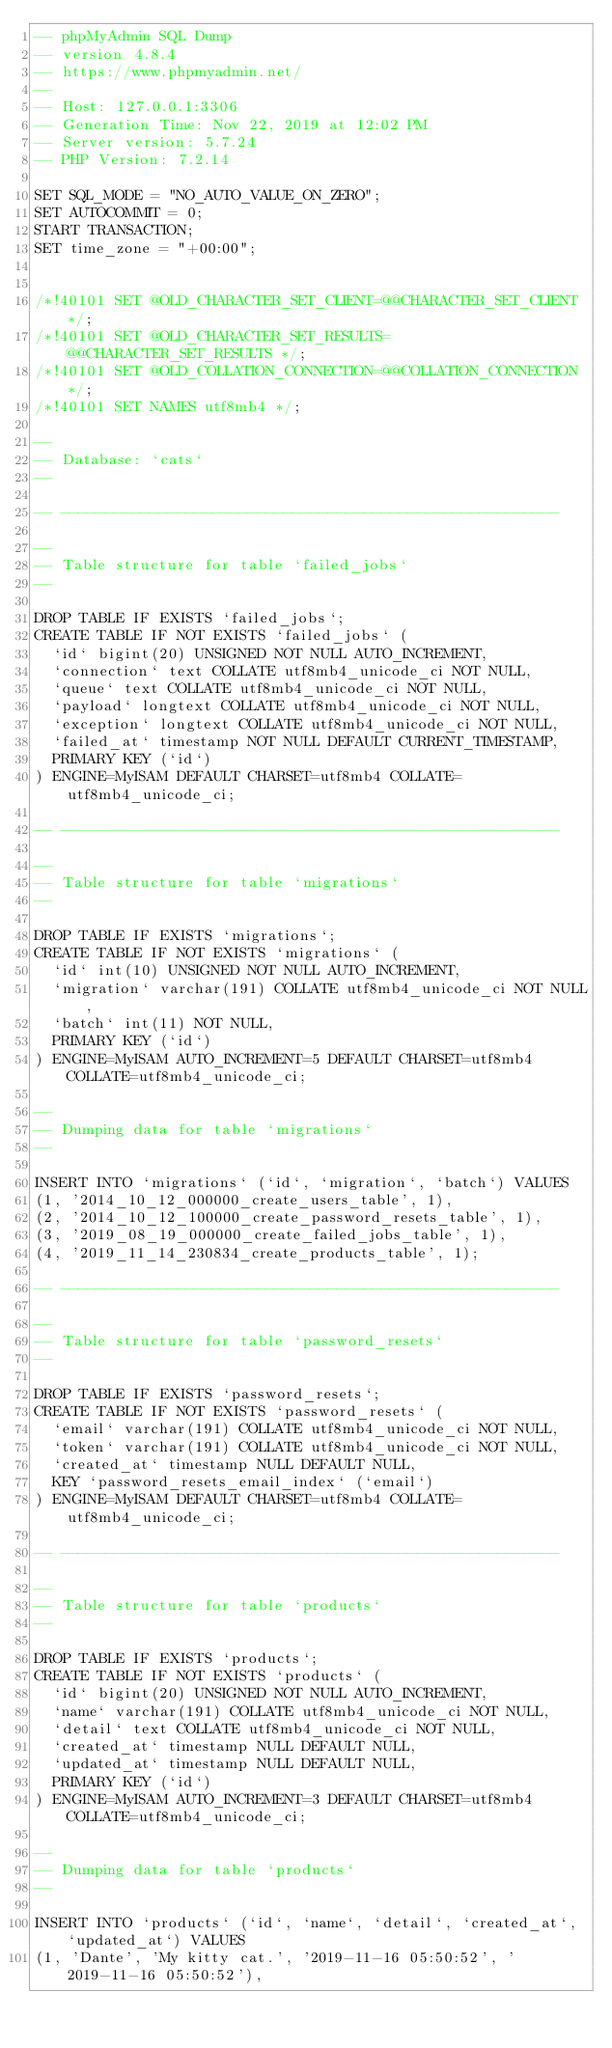<code> <loc_0><loc_0><loc_500><loc_500><_SQL_>-- phpMyAdmin SQL Dump
-- version 4.8.4
-- https://www.phpmyadmin.net/
--
-- Host: 127.0.0.1:3306
-- Generation Time: Nov 22, 2019 at 12:02 PM
-- Server version: 5.7.24
-- PHP Version: 7.2.14

SET SQL_MODE = "NO_AUTO_VALUE_ON_ZERO";
SET AUTOCOMMIT = 0;
START TRANSACTION;
SET time_zone = "+00:00";


/*!40101 SET @OLD_CHARACTER_SET_CLIENT=@@CHARACTER_SET_CLIENT */;
/*!40101 SET @OLD_CHARACTER_SET_RESULTS=@@CHARACTER_SET_RESULTS */;
/*!40101 SET @OLD_COLLATION_CONNECTION=@@COLLATION_CONNECTION */;
/*!40101 SET NAMES utf8mb4 */;

--
-- Database: `cats`
--

-- --------------------------------------------------------

--
-- Table structure for table `failed_jobs`
--

DROP TABLE IF EXISTS `failed_jobs`;
CREATE TABLE IF NOT EXISTS `failed_jobs` (
  `id` bigint(20) UNSIGNED NOT NULL AUTO_INCREMENT,
  `connection` text COLLATE utf8mb4_unicode_ci NOT NULL,
  `queue` text COLLATE utf8mb4_unicode_ci NOT NULL,
  `payload` longtext COLLATE utf8mb4_unicode_ci NOT NULL,
  `exception` longtext COLLATE utf8mb4_unicode_ci NOT NULL,
  `failed_at` timestamp NOT NULL DEFAULT CURRENT_TIMESTAMP,
  PRIMARY KEY (`id`)
) ENGINE=MyISAM DEFAULT CHARSET=utf8mb4 COLLATE=utf8mb4_unicode_ci;

-- --------------------------------------------------------

--
-- Table structure for table `migrations`
--

DROP TABLE IF EXISTS `migrations`;
CREATE TABLE IF NOT EXISTS `migrations` (
  `id` int(10) UNSIGNED NOT NULL AUTO_INCREMENT,
  `migration` varchar(191) COLLATE utf8mb4_unicode_ci NOT NULL,
  `batch` int(11) NOT NULL,
  PRIMARY KEY (`id`)
) ENGINE=MyISAM AUTO_INCREMENT=5 DEFAULT CHARSET=utf8mb4 COLLATE=utf8mb4_unicode_ci;

--
-- Dumping data for table `migrations`
--

INSERT INTO `migrations` (`id`, `migration`, `batch`) VALUES
(1, '2014_10_12_000000_create_users_table', 1),
(2, '2014_10_12_100000_create_password_resets_table', 1),
(3, '2019_08_19_000000_create_failed_jobs_table', 1),
(4, '2019_11_14_230834_create_products_table', 1);

-- --------------------------------------------------------

--
-- Table structure for table `password_resets`
--

DROP TABLE IF EXISTS `password_resets`;
CREATE TABLE IF NOT EXISTS `password_resets` (
  `email` varchar(191) COLLATE utf8mb4_unicode_ci NOT NULL,
  `token` varchar(191) COLLATE utf8mb4_unicode_ci NOT NULL,
  `created_at` timestamp NULL DEFAULT NULL,
  KEY `password_resets_email_index` (`email`)
) ENGINE=MyISAM DEFAULT CHARSET=utf8mb4 COLLATE=utf8mb4_unicode_ci;

-- --------------------------------------------------------

--
-- Table structure for table `products`
--

DROP TABLE IF EXISTS `products`;
CREATE TABLE IF NOT EXISTS `products` (
  `id` bigint(20) UNSIGNED NOT NULL AUTO_INCREMENT,
  `name` varchar(191) COLLATE utf8mb4_unicode_ci NOT NULL,
  `detail` text COLLATE utf8mb4_unicode_ci NOT NULL,
  `created_at` timestamp NULL DEFAULT NULL,
  `updated_at` timestamp NULL DEFAULT NULL,
  PRIMARY KEY (`id`)
) ENGINE=MyISAM AUTO_INCREMENT=3 DEFAULT CHARSET=utf8mb4 COLLATE=utf8mb4_unicode_ci;

--
-- Dumping data for table `products`
--

INSERT INTO `products` (`id`, `name`, `detail`, `created_at`, `updated_at`) VALUES
(1, 'Dante', 'My kitty cat.', '2019-11-16 05:50:52', '2019-11-16 05:50:52'),</code> 